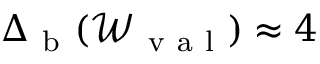Convert formula to latex. <formula><loc_0><loc_0><loc_500><loc_500>\Delta _ { b } ( \mathcal { W } _ { v a l } ) \approx 4</formula> 